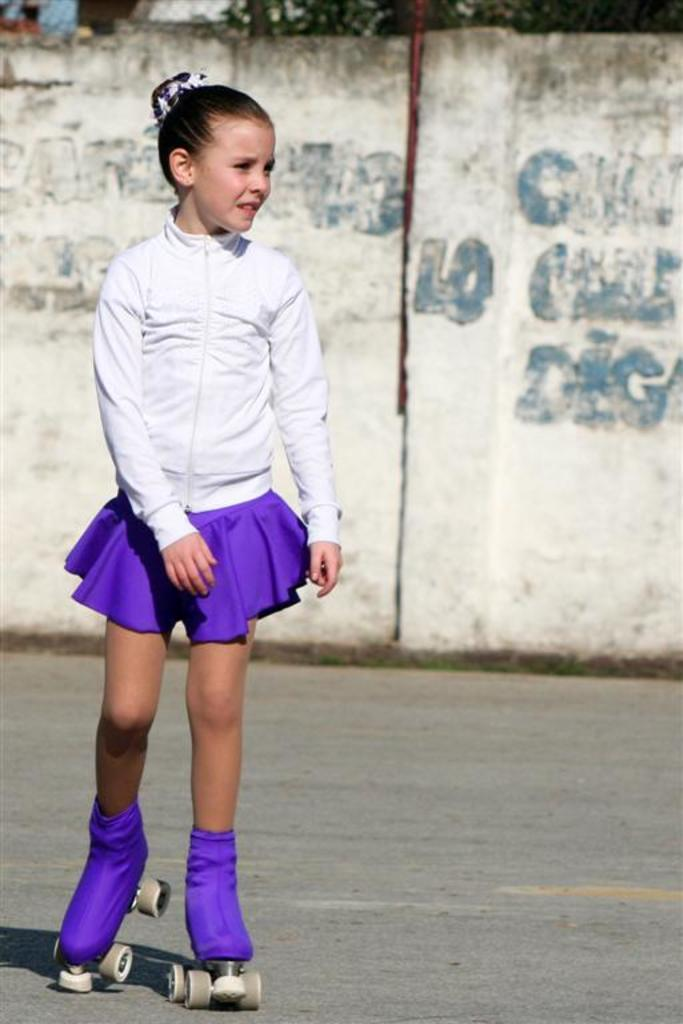Who is the main subject in the image? There is a girl in the image. What is the girl doing in the image? The girl is skating. What type of shoes is the girl wearing? The girl is wearing skate shoes. What can be seen in the background of the image? There is a wall in the image, and text is painted on the wall. How many lizards can be seen sunbathing on the girl's skate shoes in the image? There are no lizards present in the image, and therefore none can be seen sunbathing on the girl's skate shoes. 